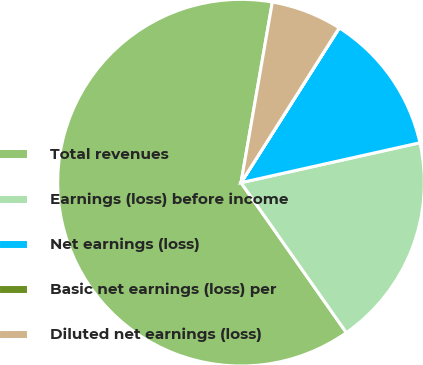<chart> <loc_0><loc_0><loc_500><loc_500><pie_chart><fcel>Total revenues<fcel>Earnings (loss) before income<fcel>Net earnings (loss)<fcel>Basic net earnings (loss) per<fcel>Diluted net earnings (loss)<nl><fcel>62.47%<fcel>18.75%<fcel>12.5%<fcel>0.01%<fcel>6.26%<nl></chart> 